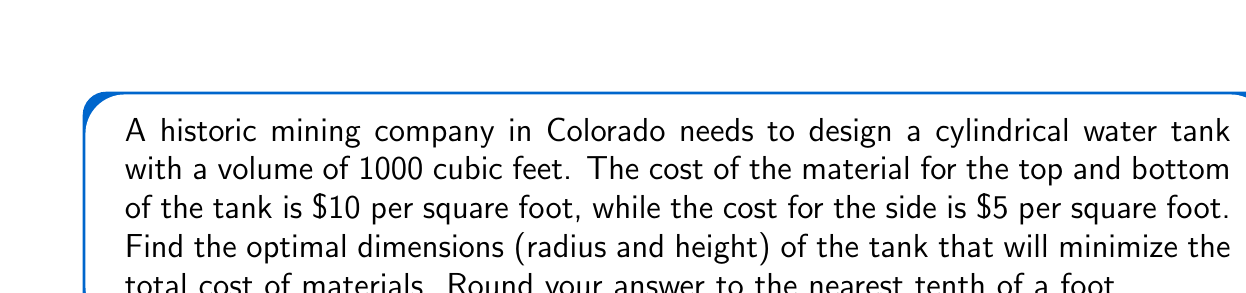Give your solution to this math problem. Let's approach this step-by-step:

1) Let $r$ be the radius and $h$ be the height of the cylinder.

2) The volume of a cylinder is $V = \pi r^2 h$. We're given that $V = 1000$ ft³, so:

   $$1000 = \pi r^2 h$$

3) We can express $h$ in terms of $r$:

   $$h = \frac{1000}{\pi r^2}$$

4) The surface area of the cylinder consists of two circular ends and the side:

   Area of top and bottom: $2\pi r^2$
   Area of side: $2\pi r h$

5) The cost function $C$ is:

   $$C = 10(2\pi r^2) + 5(2\pi r h)$$

6) Substitute $h$ from step 3:

   $$C = 20\pi r^2 + 10\pi r (\frac{1000}{\pi r^2})$$
   $$C = 20\pi r^2 + \frac{10000}{r}$$

7) To find the minimum cost, we differentiate $C$ with respect to $r$ and set it to zero:

   $$\frac{dC}{dr} = 40\pi r - \frac{10000}{r^2} = 0$$

8) Solve this equation:

   $$40\pi r^3 = 10000$$
   $$r^3 = \frac{10000}{40\pi} = \frac{250}{\pi}$$
   $$r = \sqrt[3]{\frac{250}{\pi}} \approx 4.0$$

9) Now we can find $h$ using the equation from step 3:

   $$h = \frac{1000}{\pi (4.0)^2} \approx 19.9$$

10) Rounding to the nearest tenth:

    $r \approx 4.0$ ft
    $h \approx 19.9$ ft
Answer: $r \approx 4.0$ ft, $h \approx 19.9$ ft 